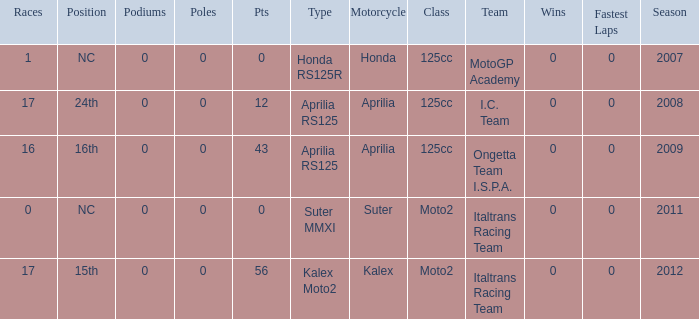How many fastest laps did I.C. Team have? 1.0. 